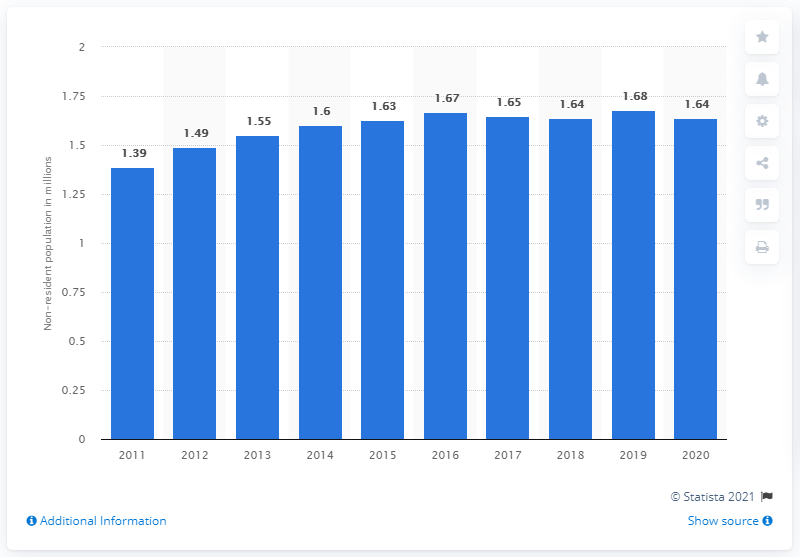List a handful of essential elements in this visual. According to data from 2020, there were 1.63 non-residents living in Singapore. 